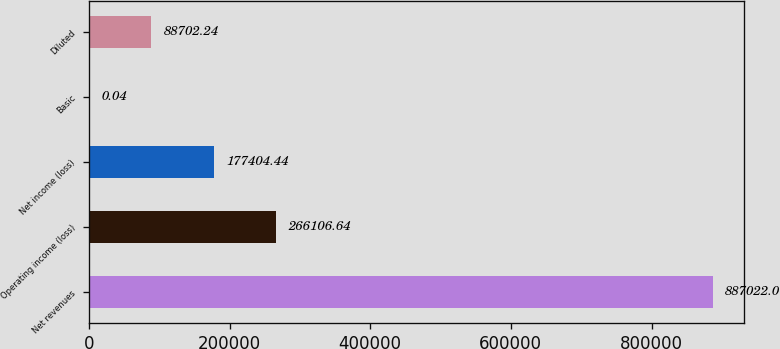Convert chart. <chart><loc_0><loc_0><loc_500><loc_500><bar_chart><fcel>Net revenues<fcel>Operating income (loss)<fcel>Net income (loss)<fcel>Basic<fcel>Diluted<nl><fcel>887022<fcel>266107<fcel>177404<fcel>0.04<fcel>88702.2<nl></chart> 